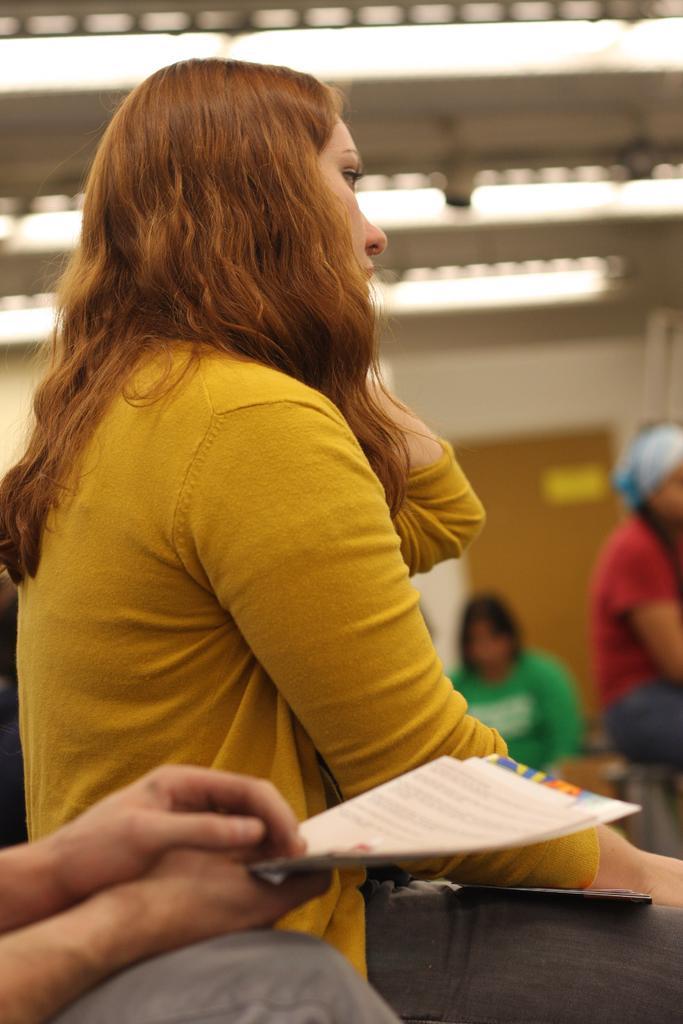How would you summarize this image in a sentence or two? In this picture we can see a girl wearing a yellow t-shirt and standing in the front. Behind we can see two girls sitting on the bench. In the background there is a white wall. On the top ceiling there are some tube lights 